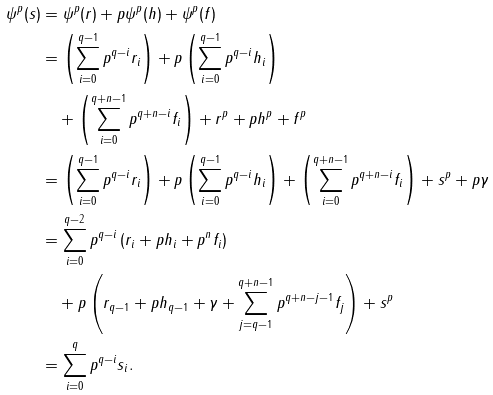<formula> <loc_0><loc_0><loc_500><loc_500>\psi ^ { p } ( s ) & = \psi ^ { p } ( r ) + p \psi ^ { p } ( h ) + \psi ^ { p } ( f ) \\ & = \left ( \sum _ { i = 0 } ^ { q - 1 } p ^ { q - i } r _ { i } \right ) + p \left ( \sum _ { i = 0 } ^ { q - 1 } p ^ { q - i } h _ { i } \right ) \\ & \quad + \left ( \sum _ { i = 0 } ^ { q + n - 1 } p ^ { q + n - i } f _ { i } \right ) + r ^ { p } + p h ^ { p } + f ^ { p } \\ & = \left ( \sum _ { i = 0 } ^ { q - 1 } p ^ { q - i } r _ { i } \right ) + p \left ( \sum _ { i = 0 } ^ { q - 1 } p ^ { q - i } h _ { i } \right ) + \left ( \sum _ { i = 0 } ^ { q + n - 1 } p ^ { q + n - i } f _ { i } \right ) + s ^ { p } + p \gamma \\ & = \sum _ { i = 0 } ^ { q - 2 } p ^ { q - i } \left ( r _ { i } + p h _ { i } + p ^ { n } f _ { i } \right ) \\ & \quad + p \left ( r _ { q - 1 } + p h _ { q - 1 } + \gamma + \sum _ { j = q - 1 } ^ { q + n - 1 } p ^ { q + n - j - 1 } f _ { j } \right ) + s ^ { p } \\ & = \sum _ { i = 0 } ^ { q } p ^ { q - i } s _ { i } .</formula> 